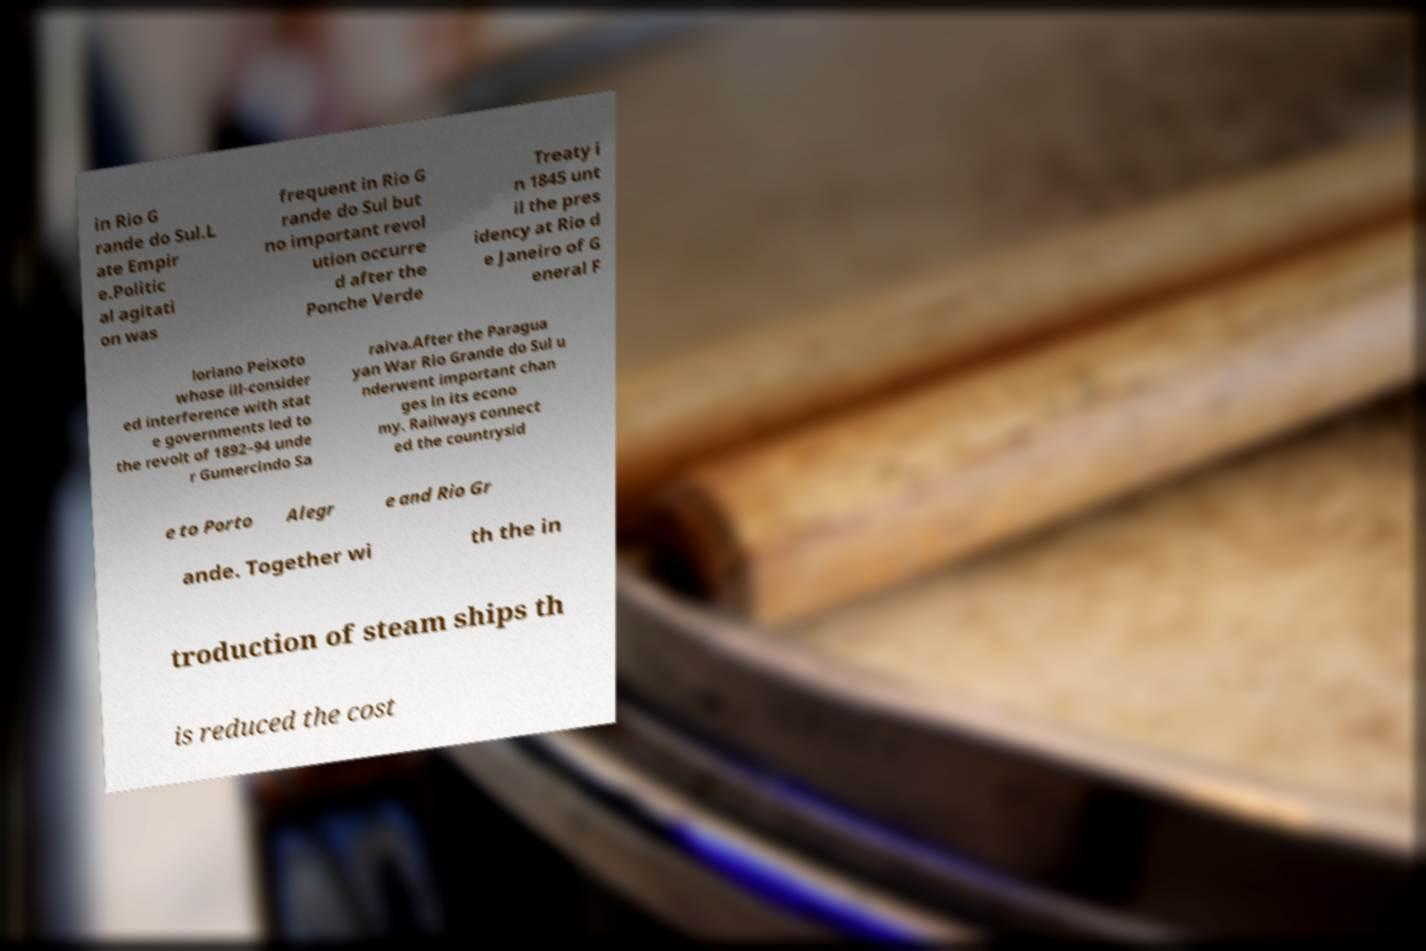Please read and relay the text visible in this image. What does it say? in Rio G rande do Sul.L ate Empir e.Politic al agitati on was frequent in Rio G rande do Sul but no important revol ution occurre d after the Ponche Verde Treaty i n 1845 unt il the pres idency at Rio d e Janeiro of G eneral F loriano Peixoto whose ill-consider ed interference with stat e governments led to the revolt of 1892–94 unde r Gumercindo Sa raiva.After the Paragua yan War Rio Grande do Sul u nderwent important chan ges in its econo my. Railways connect ed the countrysid e to Porto Alegr e and Rio Gr ande. Together wi th the in troduction of steam ships th is reduced the cost 